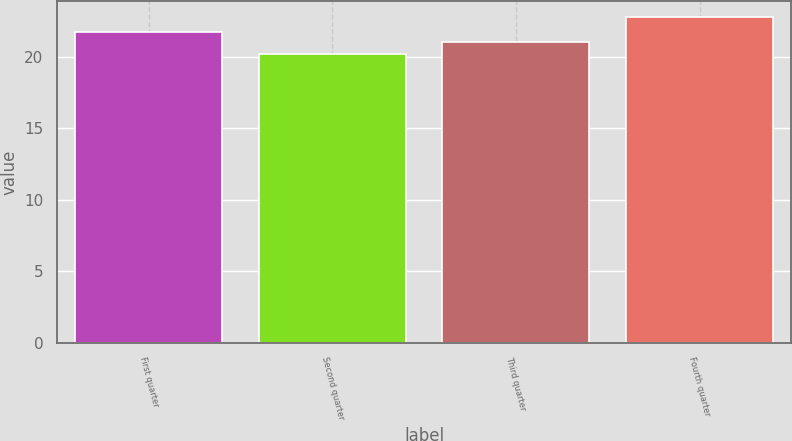Convert chart. <chart><loc_0><loc_0><loc_500><loc_500><bar_chart><fcel>First quarter<fcel>Second quarter<fcel>Third quarter<fcel>Fourth quarter<nl><fcel>21.76<fcel>20.18<fcel>21.07<fcel>22.76<nl></chart> 